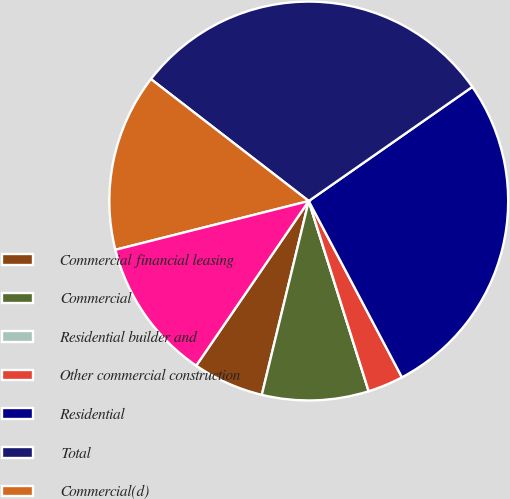<chart> <loc_0><loc_0><loc_500><loc_500><pie_chart><fcel>Commercial financial leasing<fcel>Commercial<fcel>Residential builder and<fcel>Other commercial construction<fcel>Residential<fcel>Total<fcel>Commercial(d)<fcel>Other commercial<nl><fcel>5.76%<fcel>8.64%<fcel>0.0%<fcel>2.88%<fcel>26.95%<fcel>29.83%<fcel>14.4%<fcel>11.52%<nl></chart> 